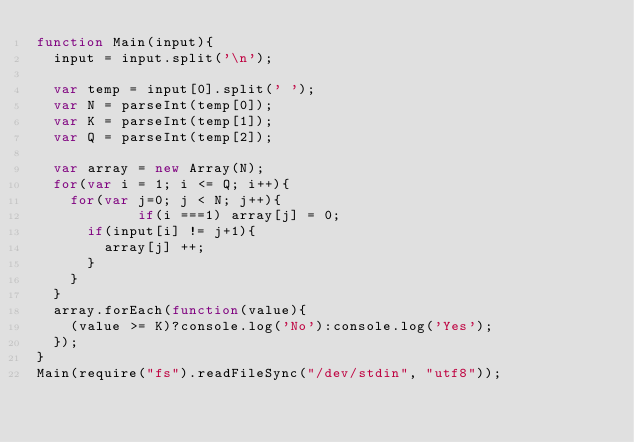<code> <loc_0><loc_0><loc_500><loc_500><_JavaScript_>function Main(input){
  input = input.split('\n');

  var temp = input[0].split(' ');
  var N = parseInt(temp[0]);
  var K = parseInt(temp[1]);
  var Q = parseInt(temp[2]);

  var array = new Array(N);
  for(var i = 1; i <= Q; i++){
		for(var j=0; j < N; j++){
          	if(i ===1) array[j] = 0;
			if(input[i] != j+1){
				array[j] ++;
			}
		}
	}
  array.forEach(function(value){
    (value >= K)?console.log('No'):console.log('Yes');
  });
}
Main(require("fs").readFileSync("/dev/stdin", "utf8"));</code> 